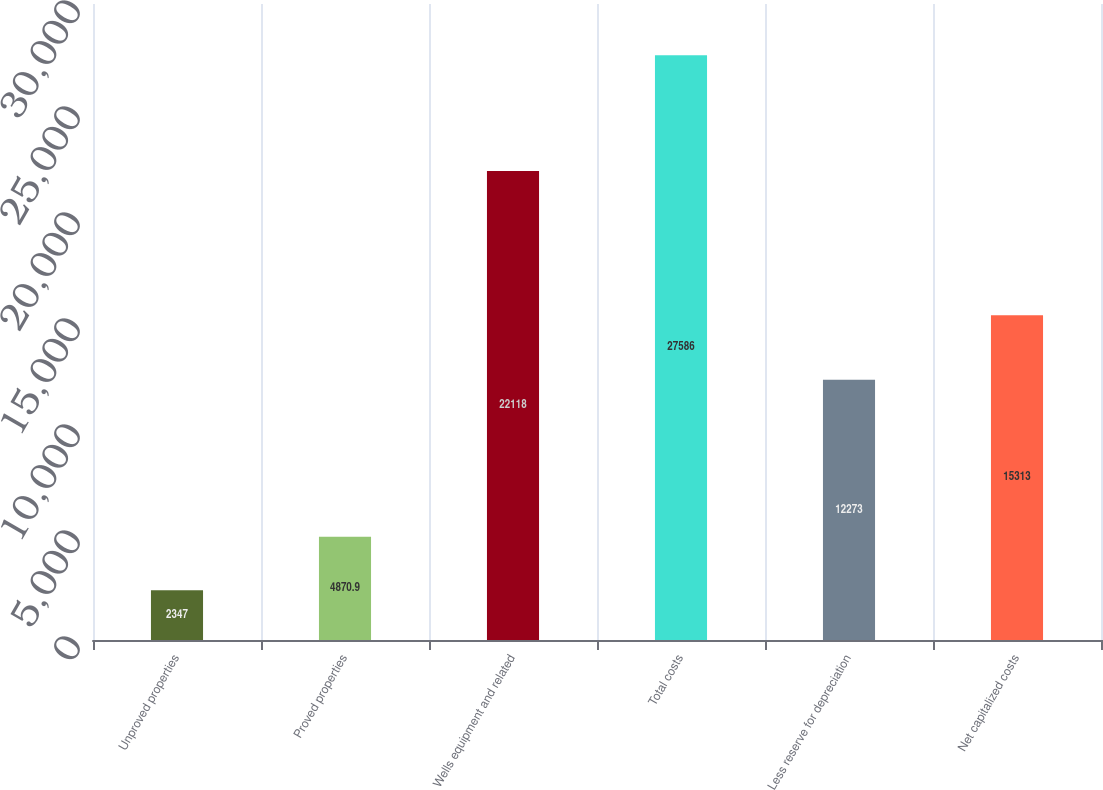<chart> <loc_0><loc_0><loc_500><loc_500><bar_chart><fcel>Unproved properties<fcel>Proved properties<fcel>Wells equipment and related<fcel>Total costs<fcel>Less reserve for depreciation<fcel>Net capitalized costs<nl><fcel>2347<fcel>4870.9<fcel>22118<fcel>27586<fcel>12273<fcel>15313<nl></chart> 